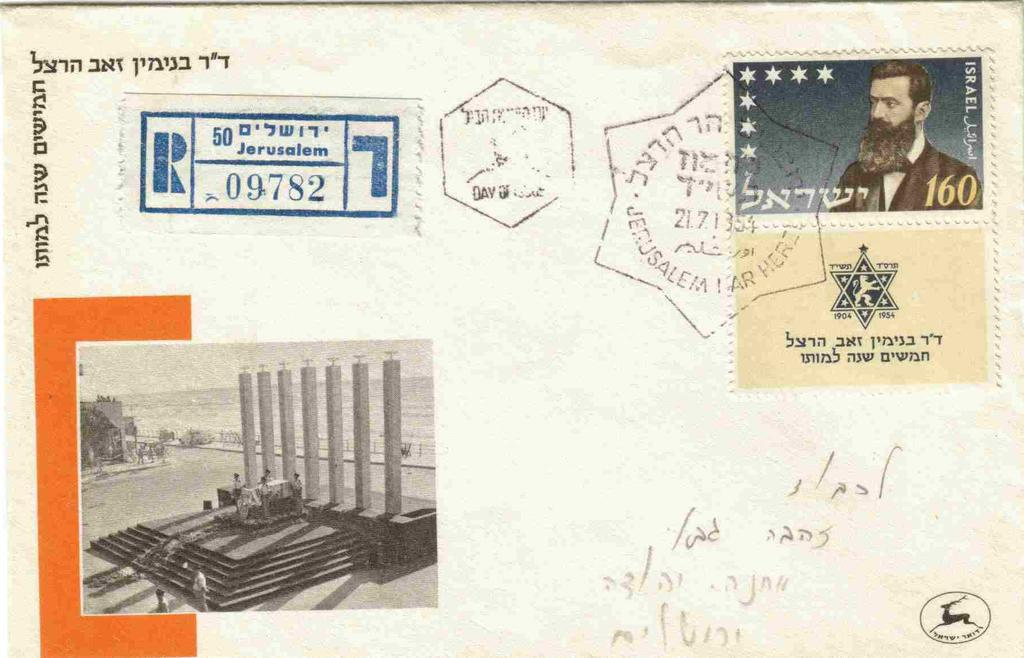<image>
Summarize the visual content of the image. A postcard which accrding to the postmark has been sent from Israel. 